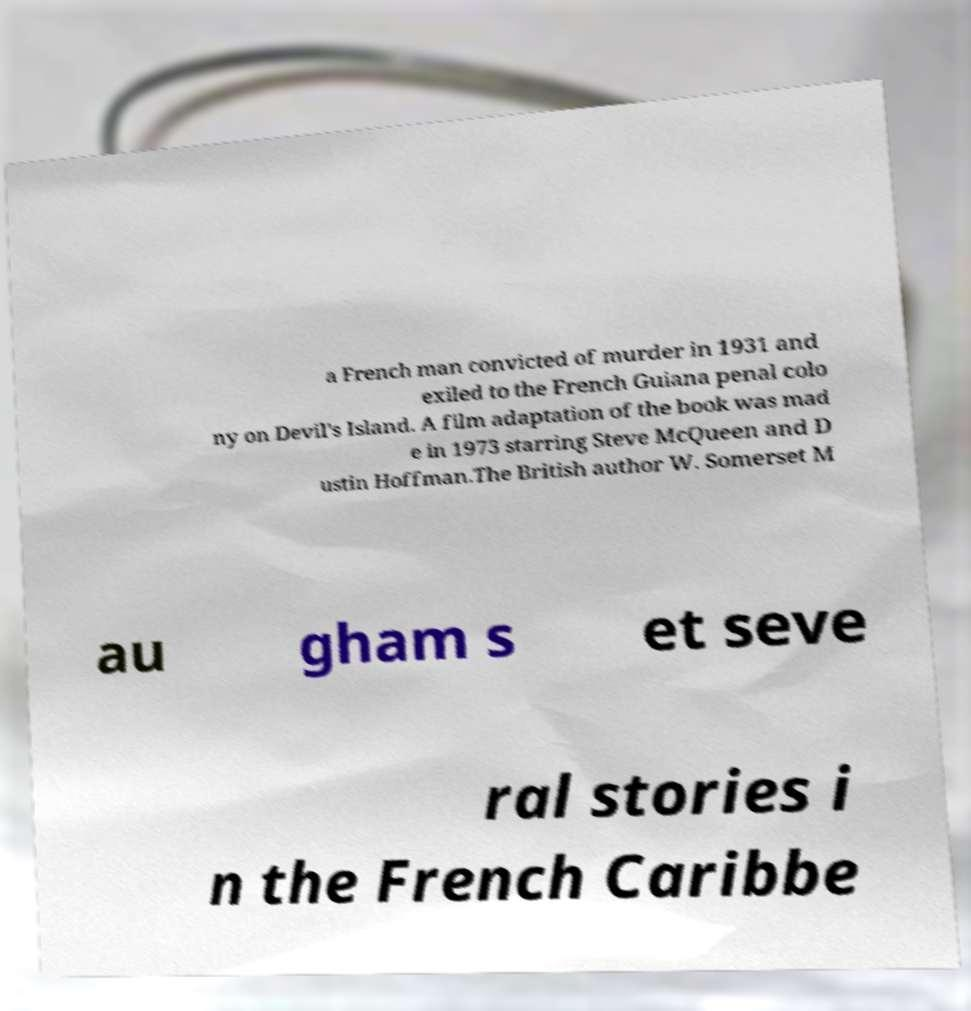There's text embedded in this image that I need extracted. Can you transcribe it verbatim? a French man convicted of murder in 1931 and exiled to the French Guiana penal colo ny on Devil's Island. A film adaptation of the book was mad e in 1973 starring Steve McQueen and D ustin Hoffman.The British author W. Somerset M au gham s et seve ral stories i n the French Caribbe 